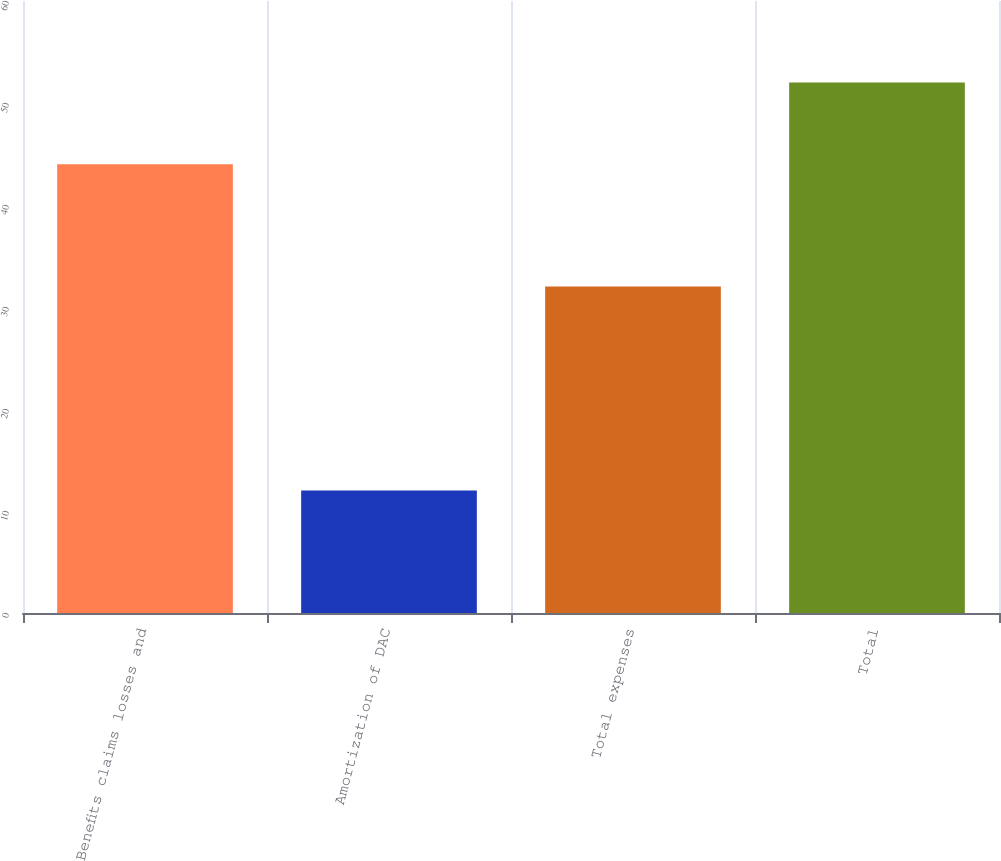Convert chart. <chart><loc_0><loc_0><loc_500><loc_500><bar_chart><fcel>Benefits claims losses and<fcel>Amortization of DAC<fcel>Total expenses<fcel>Total<nl><fcel>44<fcel>12<fcel>32<fcel>52<nl></chart> 